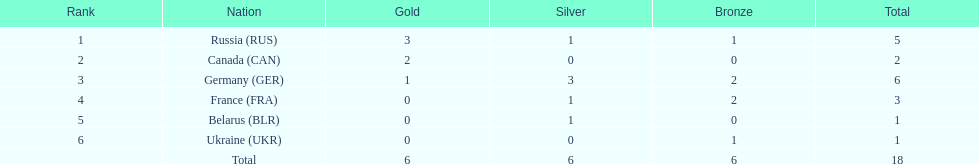Which country won the same amount of silver medals as the french and the russians? Belarus. 